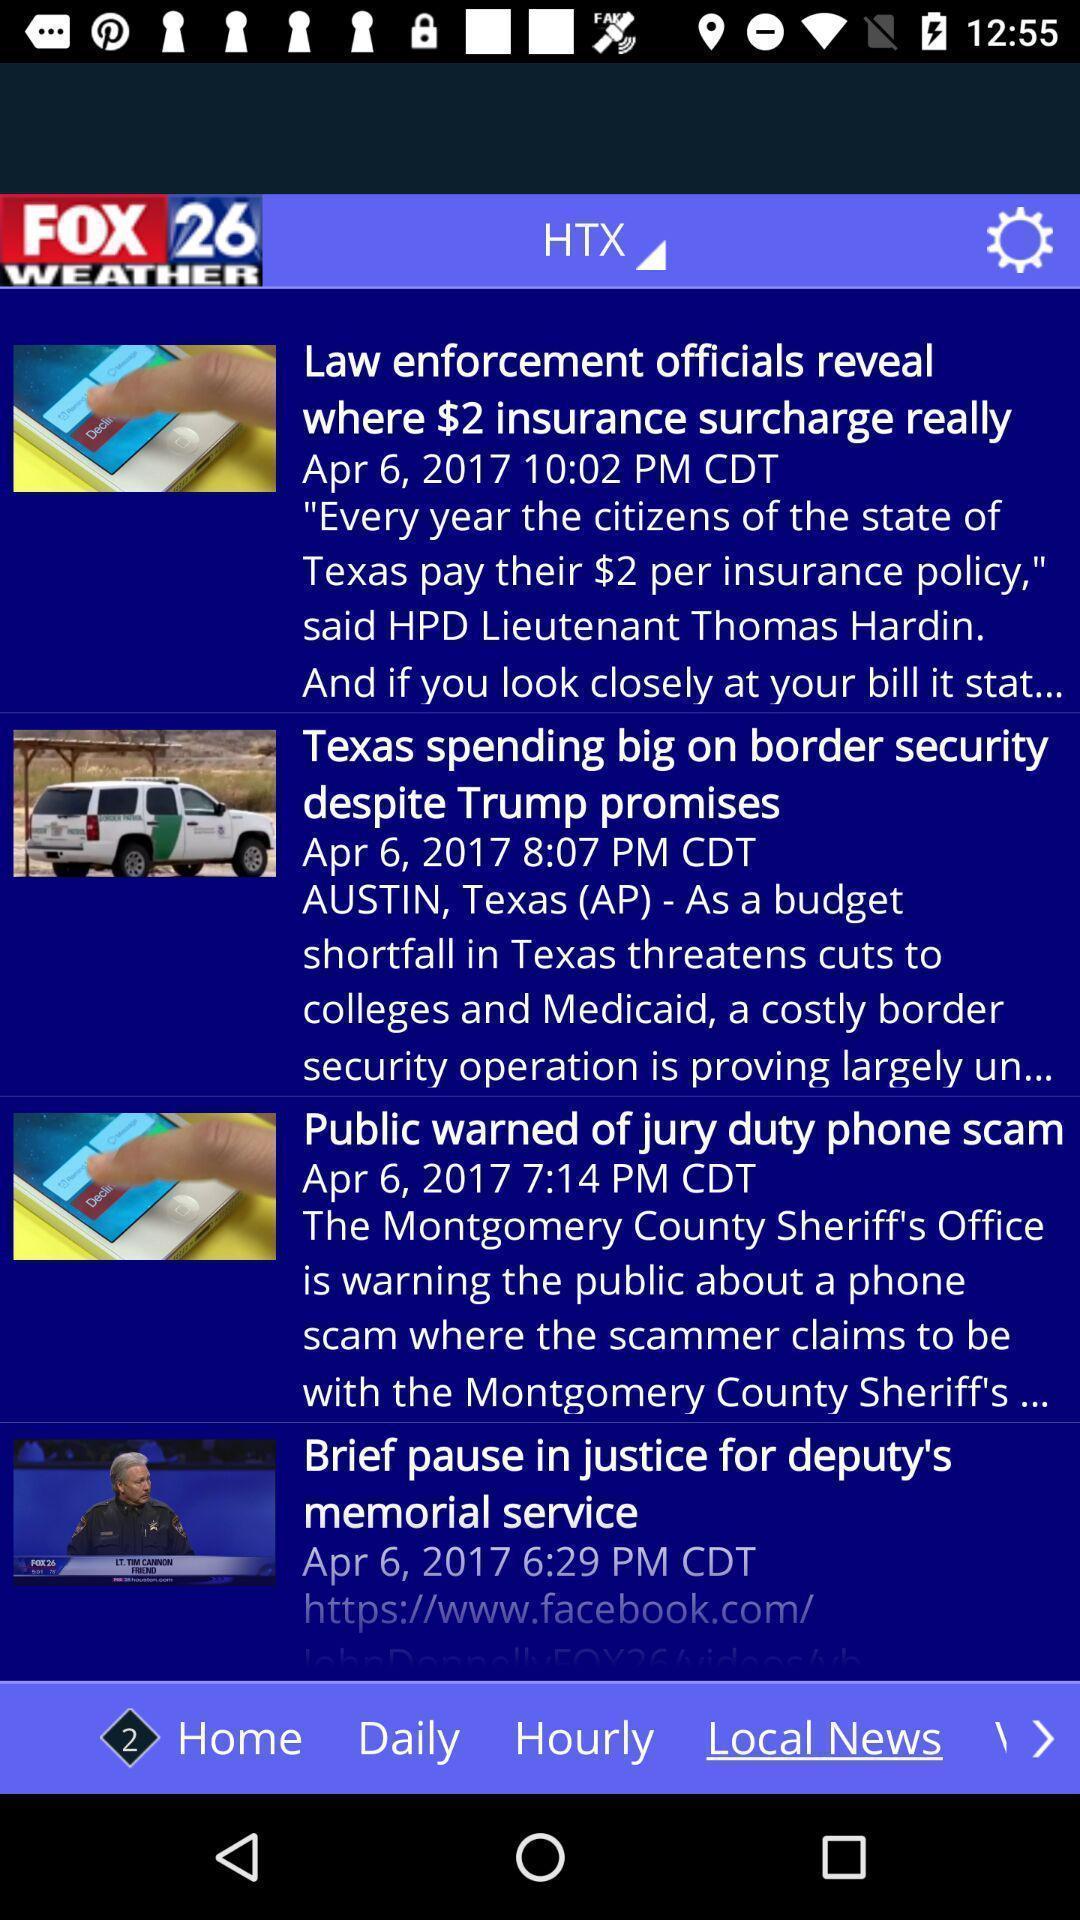Provide a description of this screenshot. Window displaying the news articles. 